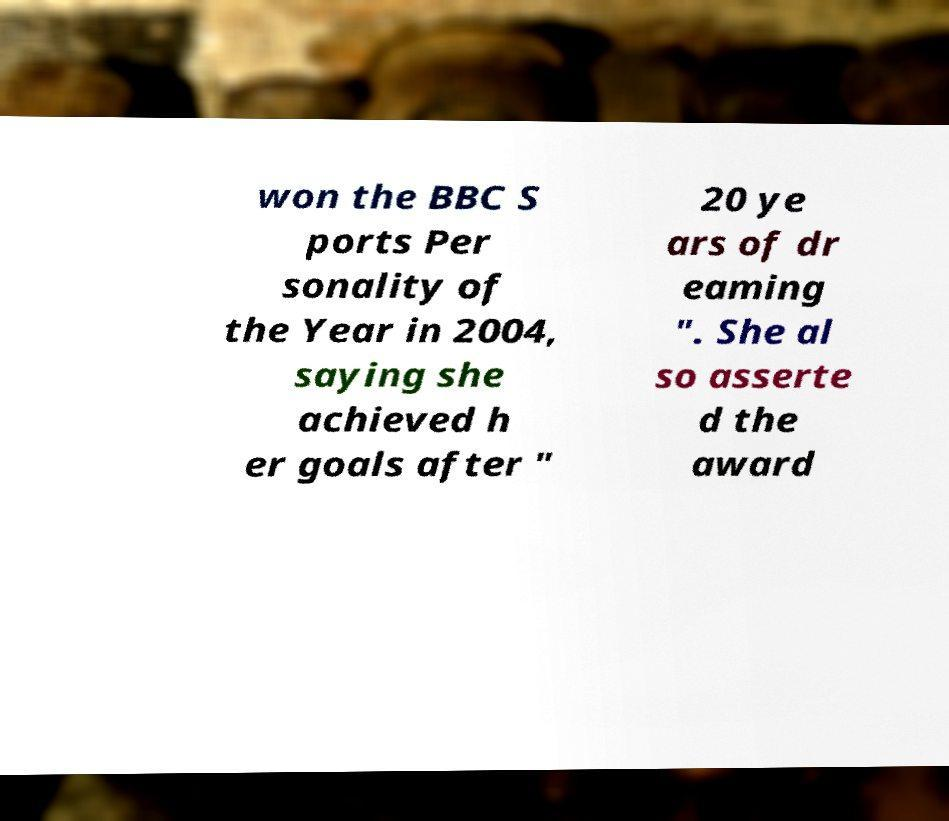Could you assist in decoding the text presented in this image and type it out clearly? won the BBC S ports Per sonality of the Year in 2004, saying she achieved h er goals after " 20 ye ars of dr eaming ". She al so asserte d the award 